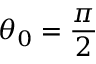<formula> <loc_0><loc_0><loc_500><loc_500>\theta _ { 0 } = \frac { \pi } { 2 }</formula> 